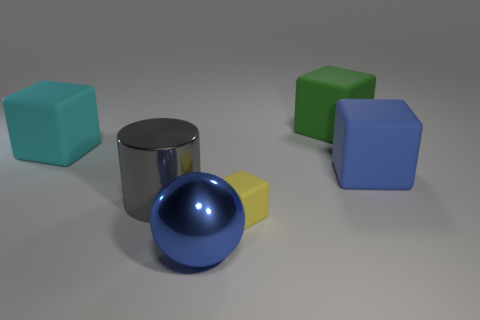What number of tiny purple matte spheres are there?
Keep it short and to the point. 0. Does the big blue matte object have the same shape as the large blue object in front of the small yellow rubber object?
Give a very brief answer. No. What size is the matte thing that is the same color as the big sphere?
Make the answer very short. Large. How many objects are either blue matte blocks or gray shiny balls?
Offer a terse response. 1. There is a thing behind the big block that is to the left of the green block; what is its shape?
Provide a succinct answer. Cube. Is the shape of the small rubber thing that is behind the shiny ball the same as  the green rubber object?
Keep it short and to the point. Yes. The other cyan object that is made of the same material as the tiny object is what size?
Keep it short and to the point. Large. How many things are big metallic objects to the right of the big gray metal cylinder or matte things that are right of the large cyan rubber block?
Offer a terse response. 4. Are there the same number of tiny matte blocks left of the small yellow cube and big green matte blocks right of the green rubber cube?
Offer a terse response. Yes. What is the color of the large matte thing that is on the left side of the tiny matte cube?
Your answer should be compact. Cyan. 